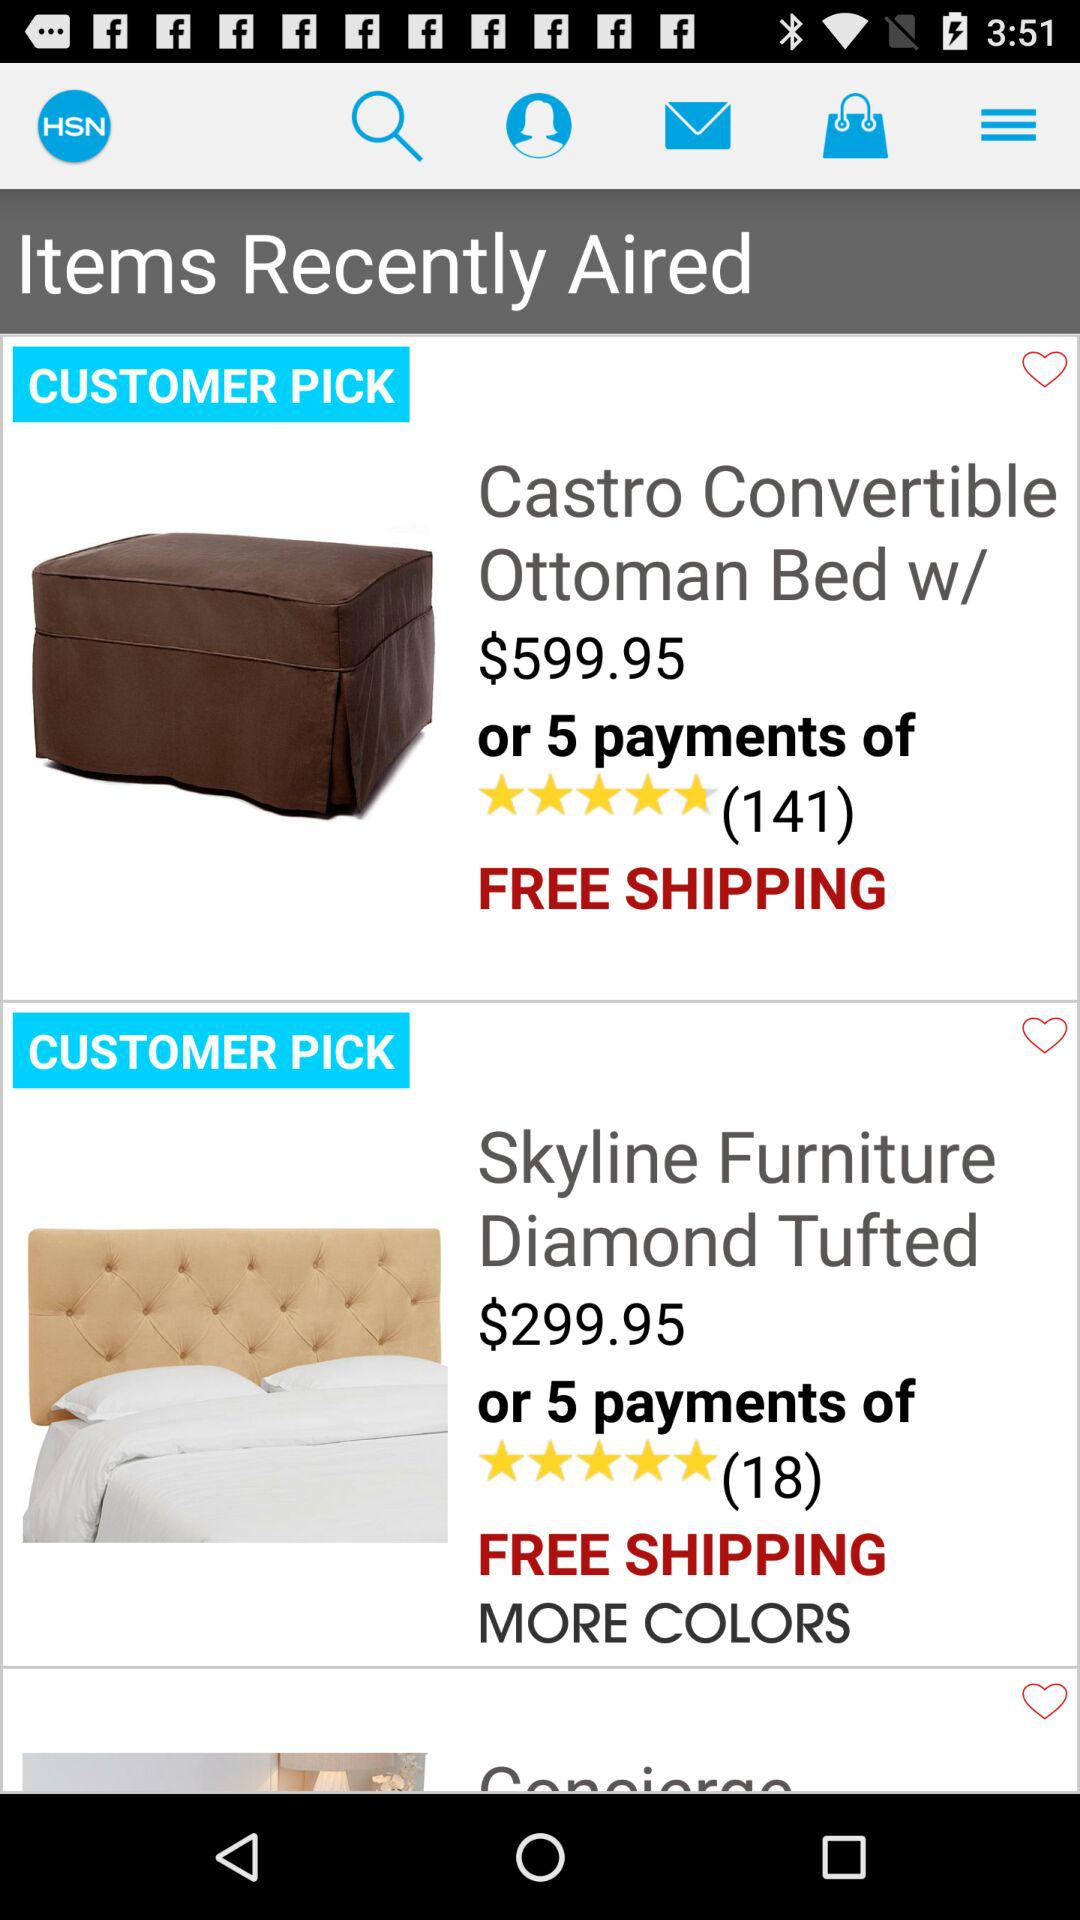What is the name of the application? The name of the application is "HSN". 